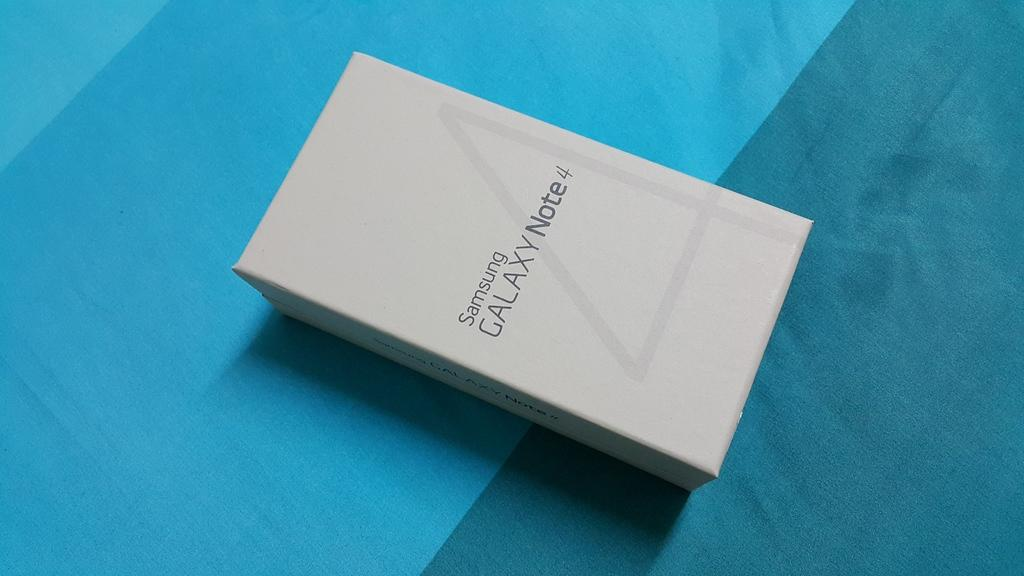Provide a one-sentence caption for the provided image. Samsung galaxy note four new in box on a table. 